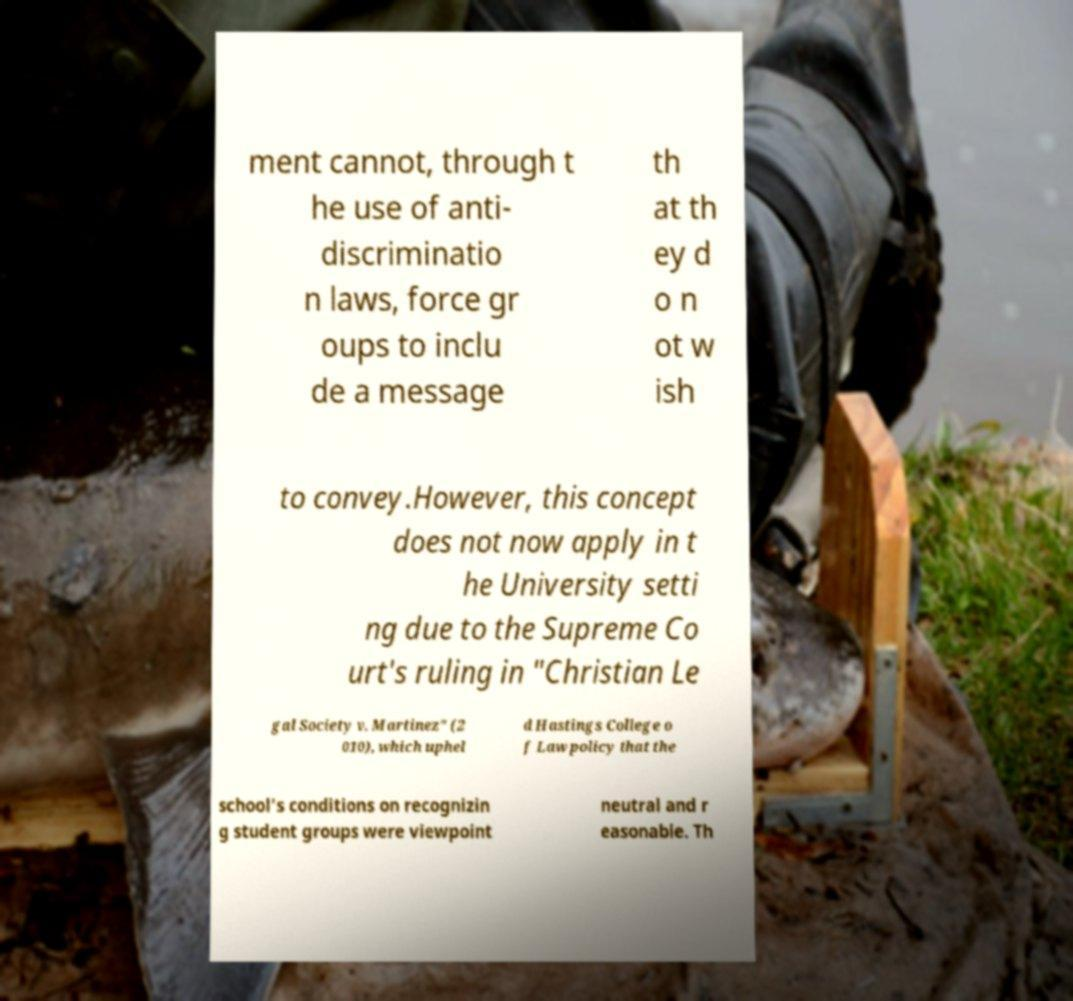I need the written content from this picture converted into text. Can you do that? ment cannot, through t he use of anti- discriminatio n laws, force gr oups to inclu de a message th at th ey d o n ot w ish to convey.However, this concept does not now apply in t he University setti ng due to the Supreme Co urt's ruling in "Christian Le gal Society v. Martinez" (2 010), which uphel d Hastings College o f Law policy that the school's conditions on recognizin g student groups were viewpoint neutral and r easonable. Th 